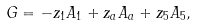<formula> <loc_0><loc_0><loc_500><loc_500>G = - z _ { 1 } A _ { 1 } + z _ { a } A _ { a } + z _ { 5 } A _ { 5 } ,</formula> 